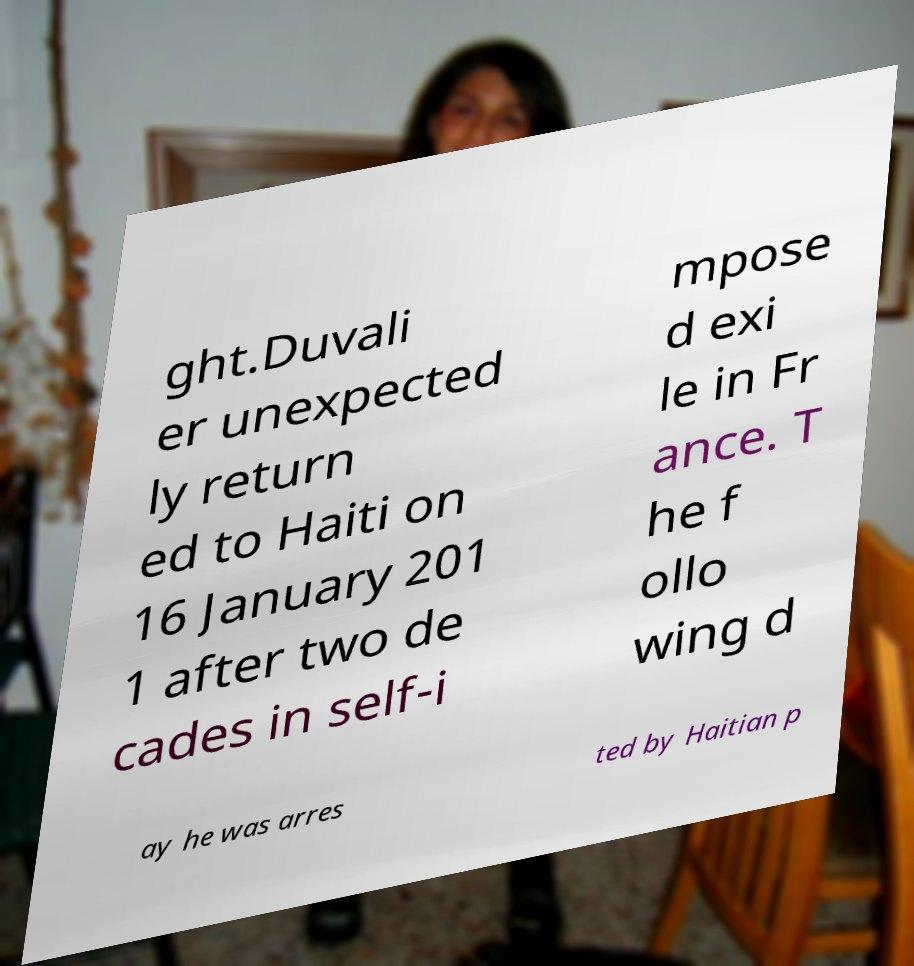There's text embedded in this image that I need extracted. Can you transcribe it verbatim? ght.Duvali er unexpected ly return ed to Haiti on 16 January 201 1 after two de cades in self-i mpose d exi le in Fr ance. T he f ollo wing d ay he was arres ted by Haitian p 